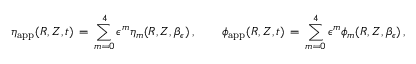<formula> <loc_0><loc_0><loc_500><loc_500>\eta _ { a p p } ( R , Z , t ) \, = \, \sum _ { m = 0 } ^ { 4 } \epsilon ^ { m } \eta _ { m } ( R , Z , \beta _ { \epsilon } ) \, , \quad \phi _ { a p p } ( R , Z , t ) \, = \, \sum _ { m = 0 } ^ { 4 } \epsilon ^ { m } \phi _ { m } ( R , Z , \beta _ { \epsilon } ) \, ,</formula> 